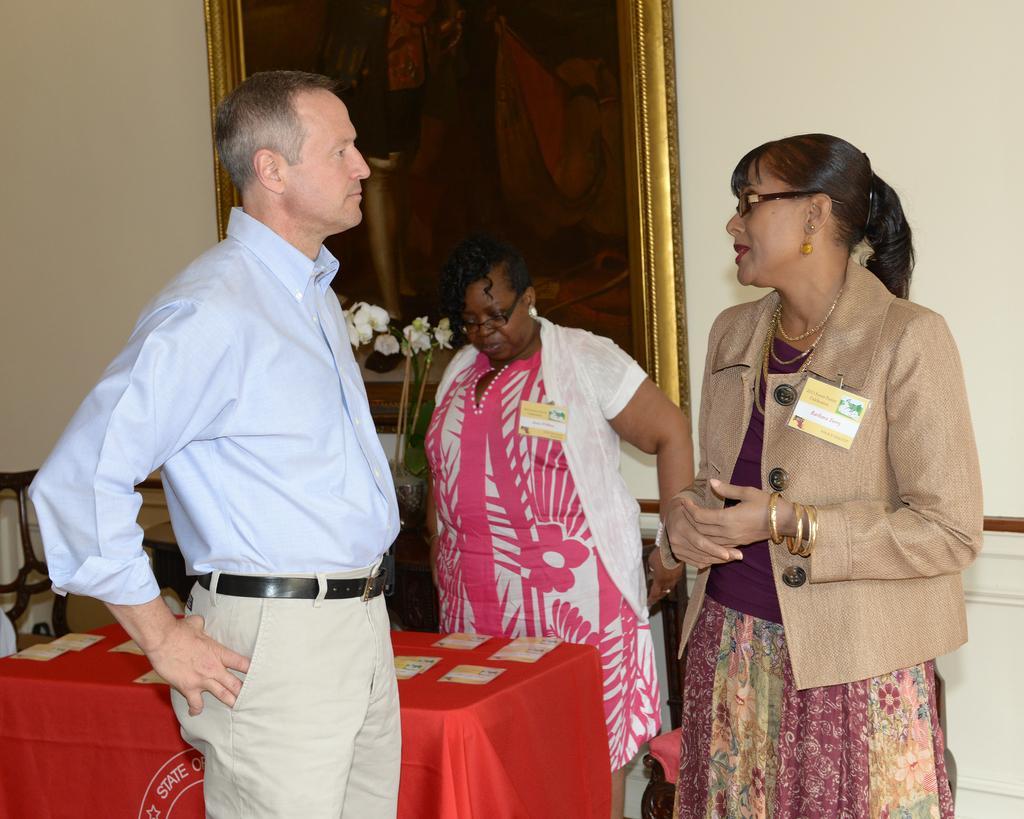Please provide a concise description of this image. There are three members in the picture. Two women and one man. Both of them are talking. There is a red table and in the background there is a photo frame and a wall. 